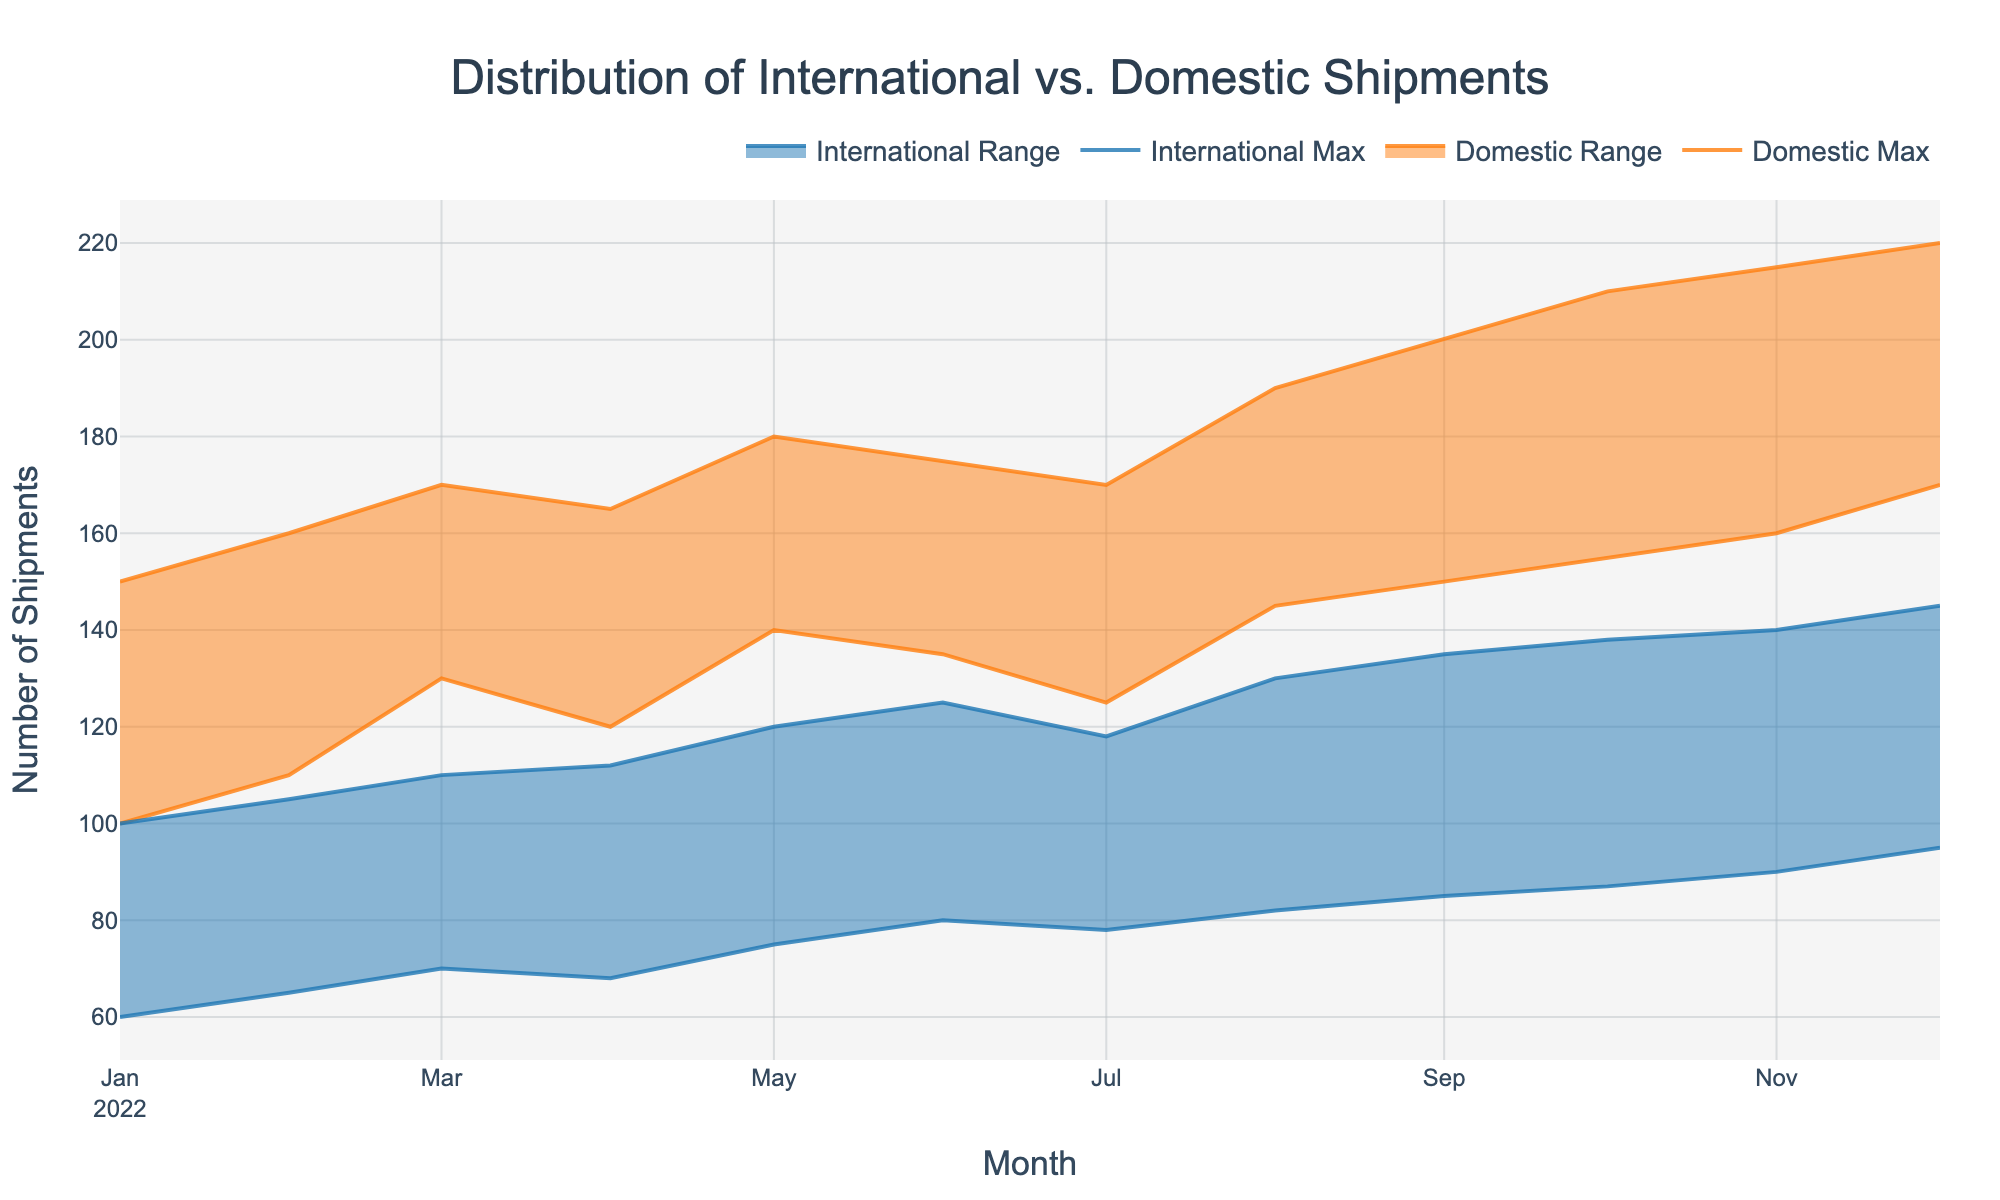What's the title of the chart? The title is usually found at the top center of the chart and is meant to give a general overview of what the chart is about.
Answer: Distribution of International vs. Domestic Shipments How are the x-axis and y-axis labeled? The x-axis usually represents time or categories, and in this chart, it is labeled "Month". The y-axis represents values and is labeled "Number of Shipments".
Answer: x-axis: Month, y-axis: Number of Shipments What colors are used to distinguish between domestic and international shipments? The colors help differentiate between the two types of shipments in the range area chart. Domestic shipments are represented with an orange color, while international shipments are represented with a blue color.
Answer: Domestic: orange, International: blue In which month was the minimum number of domestic shipments the highest? To find this, look at the "Domestic Min" line and identify the highest point on this line. The highest minimum number of domestic shipments is in December 2022.
Answer: December 2022 Which month had the largest range of international shipments? To determine this, look for the month where the difference between "International Max" and "International Min" is the greatest. This can be seen visually or calculated. For International shipments, the largest range is in December 2022.
Answer: December 2022 Comparing June 2022 and July 2022, which month had a higher maximum number of domestic shipments? Look at the "Domestic Max" values for both June and July 2022 and compare them. The maximum number in June 2022 is 175, and in July 2022 it is 170.
Answer: June 2022 On average, does the domestic range or international range of shipments appear larger? Look at the gap between the "Min" and "Max" lines for both domestic and international ranges across the months. Generally, the domestic range seems larger.
Answer: Domestic range Which month shows the narrowest domestic shipment range? To find the narrowest range, look for the smallest difference between "Domestic Min" and "Domestic Max" values across all the months. This narrowest range appears in January 2022.
Answer: January 2022 Are there any months where the minimum number of international shipments is greater than the minimum number of domestic shipments? To answer this, compare the "International Min" and "Domestic Min" values month by month. There are no months where the minimum number of international shipments exceeds the minimum number of domestic shipments.
Answer: No What trend can be observed in the maximum number of domestic shipments over the year? Look at the "Domestic Max" values from January to December. The trend shows a general increase in the maximum number of domestic shipments over the year.
Answer: Increasing trend 